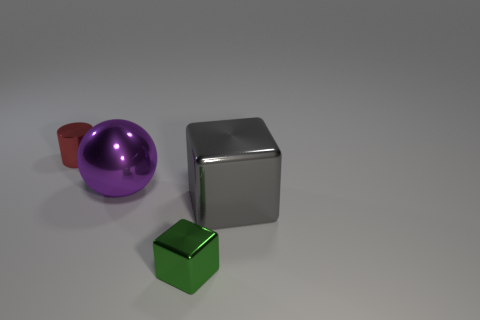Is the large gray thing the same shape as the green object?
Offer a very short reply. Yes. Are there the same number of large gray metallic objects behind the large purple ball and tiny shiny objects that are left of the tiny green thing?
Give a very brief answer. No. How many other objects are there of the same material as the large purple ball?
Offer a terse response. 3. How many tiny objects are either purple metallic balls or red matte cylinders?
Provide a short and direct response. 0. Are there the same number of tiny cylinders that are right of the large purple metal sphere and blue metal objects?
Provide a short and direct response. Yes. There is a thing that is to the right of the green metal thing; is there a big metallic thing on the left side of it?
Keep it short and to the point. Yes. The metal ball is what color?
Your answer should be very brief. Purple. What size is the thing that is both left of the green thing and to the right of the tiny red metallic object?
Offer a very short reply. Large. What number of things are metal blocks that are to the right of the green metal cube or tiny yellow shiny cylinders?
Keep it short and to the point. 1. What shape is the small green object that is the same material as the tiny red object?
Provide a succinct answer. Cube. 